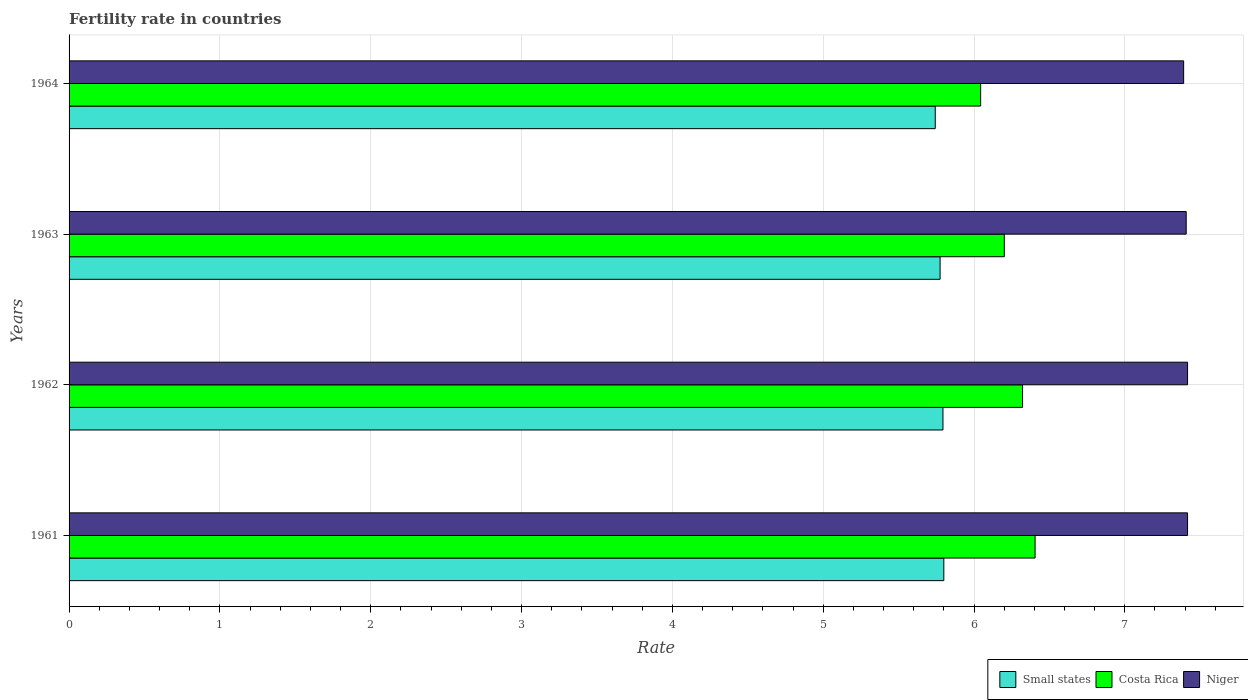How many groups of bars are there?
Keep it short and to the point. 4. How many bars are there on the 1st tick from the bottom?
Keep it short and to the point. 3. In how many cases, is the number of bars for a given year not equal to the number of legend labels?
Ensure brevity in your answer.  0. What is the fertility rate in Small states in 1962?
Keep it short and to the point. 5.79. Across all years, what is the maximum fertility rate in Small states?
Provide a short and direct response. 5.8. Across all years, what is the minimum fertility rate in Niger?
Offer a very short reply. 7.39. In which year was the fertility rate in Small states minimum?
Ensure brevity in your answer.  1964. What is the total fertility rate in Small states in the graph?
Your answer should be compact. 23.11. What is the difference between the fertility rate in Costa Rica in 1961 and that in 1963?
Offer a terse response. 0.2. What is the difference between the fertility rate in Small states in 1962 and the fertility rate in Niger in 1964?
Offer a terse response. -1.6. What is the average fertility rate in Costa Rica per year?
Keep it short and to the point. 6.24. In the year 1963, what is the difference between the fertility rate in Small states and fertility rate in Niger?
Keep it short and to the point. -1.63. What is the ratio of the fertility rate in Small states in 1961 to that in 1963?
Offer a very short reply. 1. What is the difference between the highest and the lowest fertility rate in Niger?
Offer a terse response. 0.03. What does the 2nd bar from the top in 1964 represents?
Your answer should be compact. Costa Rica. What does the 1st bar from the bottom in 1963 represents?
Your response must be concise. Small states. Is it the case that in every year, the sum of the fertility rate in Costa Rica and fertility rate in Small states is greater than the fertility rate in Niger?
Give a very brief answer. Yes. Are all the bars in the graph horizontal?
Provide a succinct answer. Yes. How many years are there in the graph?
Keep it short and to the point. 4. Are the values on the major ticks of X-axis written in scientific E-notation?
Ensure brevity in your answer.  No. Does the graph contain any zero values?
Your answer should be very brief. No. Where does the legend appear in the graph?
Your answer should be compact. Bottom right. How are the legend labels stacked?
Keep it short and to the point. Horizontal. What is the title of the graph?
Provide a short and direct response. Fertility rate in countries. Does "Afghanistan" appear as one of the legend labels in the graph?
Give a very brief answer. No. What is the label or title of the X-axis?
Ensure brevity in your answer.  Rate. What is the Rate of Small states in 1961?
Give a very brief answer. 5.8. What is the Rate of Costa Rica in 1961?
Your response must be concise. 6.41. What is the Rate of Niger in 1961?
Your answer should be very brief. 7.42. What is the Rate in Small states in 1962?
Your answer should be very brief. 5.79. What is the Rate in Costa Rica in 1962?
Your answer should be compact. 6.32. What is the Rate of Niger in 1962?
Give a very brief answer. 7.42. What is the Rate in Small states in 1963?
Provide a succinct answer. 5.78. What is the Rate of Costa Rica in 1963?
Make the answer very short. 6.2. What is the Rate of Niger in 1963?
Offer a very short reply. 7.41. What is the Rate in Small states in 1964?
Offer a terse response. 5.74. What is the Rate of Costa Rica in 1964?
Your response must be concise. 6.04. What is the Rate in Niger in 1964?
Ensure brevity in your answer.  7.39. Across all years, what is the maximum Rate of Small states?
Your answer should be compact. 5.8. Across all years, what is the maximum Rate of Costa Rica?
Your response must be concise. 6.41. Across all years, what is the maximum Rate of Niger?
Give a very brief answer. 7.42. Across all years, what is the minimum Rate in Small states?
Ensure brevity in your answer.  5.74. Across all years, what is the minimum Rate of Costa Rica?
Your answer should be compact. 6.04. Across all years, what is the minimum Rate in Niger?
Offer a terse response. 7.39. What is the total Rate in Small states in the graph?
Your answer should be compact. 23.11. What is the total Rate in Costa Rica in the graph?
Make the answer very short. 24.97. What is the total Rate in Niger in the graph?
Offer a very short reply. 29.63. What is the difference between the Rate of Small states in 1961 and that in 1962?
Offer a very short reply. 0.01. What is the difference between the Rate of Costa Rica in 1961 and that in 1962?
Ensure brevity in your answer.  0.08. What is the difference between the Rate of Niger in 1961 and that in 1962?
Offer a very short reply. 0. What is the difference between the Rate in Small states in 1961 and that in 1963?
Offer a very short reply. 0.02. What is the difference between the Rate of Costa Rica in 1961 and that in 1963?
Keep it short and to the point. 0.2. What is the difference between the Rate in Niger in 1961 and that in 1963?
Make the answer very short. 0.01. What is the difference between the Rate in Small states in 1961 and that in 1964?
Make the answer very short. 0.06. What is the difference between the Rate of Costa Rica in 1961 and that in 1964?
Give a very brief answer. 0.36. What is the difference between the Rate of Niger in 1961 and that in 1964?
Offer a terse response. 0.03. What is the difference between the Rate of Small states in 1962 and that in 1963?
Your response must be concise. 0.02. What is the difference between the Rate in Costa Rica in 1962 and that in 1963?
Keep it short and to the point. 0.12. What is the difference between the Rate in Niger in 1962 and that in 1963?
Offer a terse response. 0.01. What is the difference between the Rate of Small states in 1962 and that in 1964?
Your response must be concise. 0.05. What is the difference between the Rate in Costa Rica in 1962 and that in 1964?
Offer a terse response. 0.28. What is the difference between the Rate of Niger in 1962 and that in 1964?
Offer a terse response. 0.03. What is the difference between the Rate of Small states in 1963 and that in 1964?
Provide a succinct answer. 0.03. What is the difference between the Rate of Costa Rica in 1963 and that in 1964?
Offer a terse response. 0.16. What is the difference between the Rate in Niger in 1963 and that in 1964?
Offer a terse response. 0.02. What is the difference between the Rate in Small states in 1961 and the Rate in Costa Rica in 1962?
Provide a succinct answer. -0.52. What is the difference between the Rate in Small states in 1961 and the Rate in Niger in 1962?
Ensure brevity in your answer.  -1.62. What is the difference between the Rate in Costa Rica in 1961 and the Rate in Niger in 1962?
Keep it short and to the point. -1.01. What is the difference between the Rate in Small states in 1961 and the Rate in Costa Rica in 1963?
Your response must be concise. -0.4. What is the difference between the Rate in Small states in 1961 and the Rate in Niger in 1963?
Make the answer very short. -1.61. What is the difference between the Rate in Costa Rica in 1961 and the Rate in Niger in 1963?
Offer a terse response. -1. What is the difference between the Rate of Small states in 1961 and the Rate of Costa Rica in 1964?
Provide a succinct answer. -0.24. What is the difference between the Rate in Small states in 1961 and the Rate in Niger in 1964?
Your answer should be compact. -1.59. What is the difference between the Rate of Costa Rica in 1961 and the Rate of Niger in 1964?
Your answer should be very brief. -0.98. What is the difference between the Rate in Small states in 1962 and the Rate in Costa Rica in 1963?
Your answer should be compact. -0.41. What is the difference between the Rate in Small states in 1962 and the Rate in Niger in 1963?
Ensure brevity in your answer.  -1.61. What is the difference between the Rate of Costa Rica in 1962 and the Rate of Niger in 1963?
Keep it short and to the point. -1.08. What is the difference between the Rate in Small states in 1962 and the Rate in Costa Rica in 1964?
Make the answer very short. -0.25. What is the difference between the Rate in Small states in 1962 and the Rate in Niger in 1964?
Make the answer very short. -1.6. What is the difference between the Rate of Costa Rica in 1962 and the Rate of Niger in 1964?
Your answer should be very brief. -1.07. What is the difference between the Rate of Small states in 1963 and the Rate of Costa Rica in 1964?
Give a very brief answer. -0.27. What is the difference between the Rate in Small states in 1963 and the Rate in Niger in 1964?
Provide a short and direct response. -1.61. What is the difference between the Rate of Costa Rica in 1963 and the Rate of Niger in 1964?
Make the answer very short. -1.19. What is the average Rate of Small states per year?
Your answer should be very brief. 5.78. What is the average Rate of Costa Rica per year?
Ensure brevity in your answer.  6.24. What is the average Rate of Niger per year?
Provide a succinct answer. 7.41. In the year 1961, what is the difference between the Rate in Small states and Rate in Costa Rica?
Offer a terse response. -0.61. In the year 1961, what is the difference between the Rate in Small states and Rate in Niger?
Offer a very short reply. -1.62. In the year 1961, what is the difference between the Rate in Costa Rica and Rate in Niger?
Keep it short and to the point. -1.01. In the year 1962, what is the difference between the Rate of Small states and Rate of Costa Rica?
Ensure brevity in your answer.  -0.53. In the year 1962, what is the difference between the Rate of Small states and Rate of Niger?
Ensure brevity in your answer.  -1.62. In the year 1962, what is the difference between the Rate of Costa Rica and Rate of Niger?
Keep it short and to the point. -1.09. In the year 1963, what is the difference between the Rate of Small states and Rate of Costa Rica?
Ensure brevity in your answer.  -0.43. In the year 1963, what is the difference between the Rate in Small states and Rate in Niger?
Provide a succinct answer. -1.63. In the year 1963, what is the difference between the Rate of Costa Rica and Rate of Niger?
Keep it short and to the point. -1.21. In the year 1964, what is the difference between the Rate of Small states and Rate of Costa Rica?
Ensure brevity in your answer.  -0.3. In the year 1964, what is the difference between the Rate of Small states and Rate of Niger?
Provide a succinct answer. -1.65. In the year 1964, what is the difference between the Rate in Costa Rica and Rate in Niger?
Your answer should be compact. -1.35. What is the ratio of the Rate in Costa Rica in 1961 to that in 1962?
Keep it short and to the point. 1.01. What is the ratio of the Rate in Niger in 1961 to that in 1962?
Keep it short and to the point. 1. What is the ratio of the Rate in Small states in 1961 to that in 1963?
Keep it short and to the point. 1. What is the ratio of the Rate in Costa Rica in 1961 to that in 1963?
Offer a terse response. 1.03. What is the ratio of the Rate of Niger in 1961 to that in 1963?
Offer a terse response. 1. What is the ratio of the Rate of Small states in 1961 to that in 1964?
Provide a succinct answer. 1.01. What is the ratio of the Rate of Costa Rica in 1961 to that in 1964?
Your answer should be very brief. 1.06. What is the ratio of the Rate in Niger in 1961 to that in 1964?
Your response must be concise. 1. What is the ratio of the Rate of Small states in 1962 to that in 1963?
Offer a terse response. 1. What is the ratio of the Rate of Costa Rica in 1962 to that in 1963?
Provide a short and direct response. 1.02. What is the ratio of the Rate in Small states in 1962 to that in 1964?
Your answer should be compact. 1.01. What is the ratio of the Rate in Costa Rica in 1962 to that in 1964?
Offer a very short reply. 1.05. What is the ratio of the Rate of Small states in 1963 to that in 1964?
Provide a succinct answer. 1.01. What is the difference between the highest and the second highest Rate in Small states?
Give a very brief answer. 0.01. What is the difference between the highest and the second highest Rate in Costa Rica?
Your answer should be compact. 0.08. What is the difference between the highest and the lowest Rate in Small states?
Give a very brief answer. 0.06. What is the difference between the highest and the lowest Rate of Costa Rica?
Provide a short and direct response. 0.36. What is the difference between the highest and the lowest Rate of Niger?
Keep it short and to the point. 0.03. 